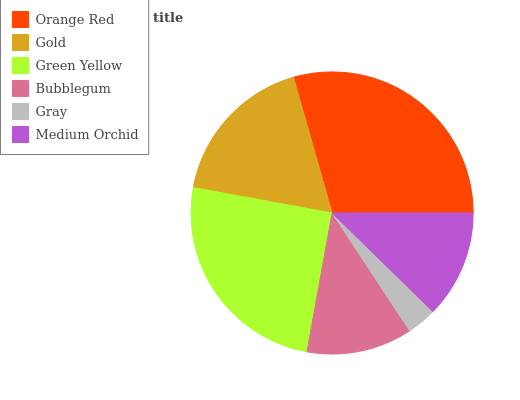Is Gray the minimum?
Answer yes or no. Yes. Is Orange Red the maximum?
Answer yes or no. Yes. Is Gold the minimum?
Answer yes or no. No. Is Gold the maximum?
Answer yes or no. No. Is Orange Red greater than Gold?
Answer yes or no. Yes. Is Gold less than Orange Red?
Answer yes or no. Yes. Is Gold greater than Orange Red?
Answer yes or no. No. Is Orange Red less than Gold?
Answer yes or no. No. Is Gold the high median?
Answer yes or no. Yes. Is Medium Orchid the low median?
Answer yes or no. Yes. Is Medium Orchid the high median?
Answer yes or no. No. Is Gold the low median?
Answer yes or no. No. 